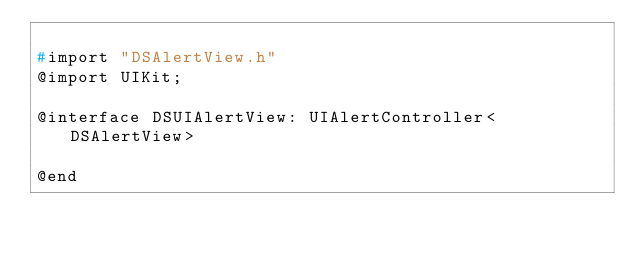Convert code to text. <code><loc_0><loc_0><loc_500><loc_500><_C_>
#import "DSAlertView.h"
@import UIKit;

@interface DSUIAlertView: UIAlertController<DSAlertView>

@end
</code> 